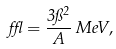<formula> <loc_0><loc_0><loc_500><loc_500>\epsilon = \frac { 3 \pi ^ { 2 } } { A } \, { M e V } ,</formula> 